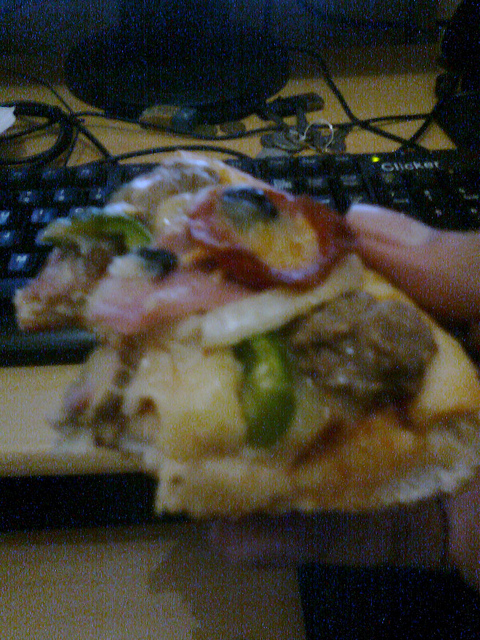Is this food on a tray? No, the pizza is being held directly by hand, not placed on any tray. 